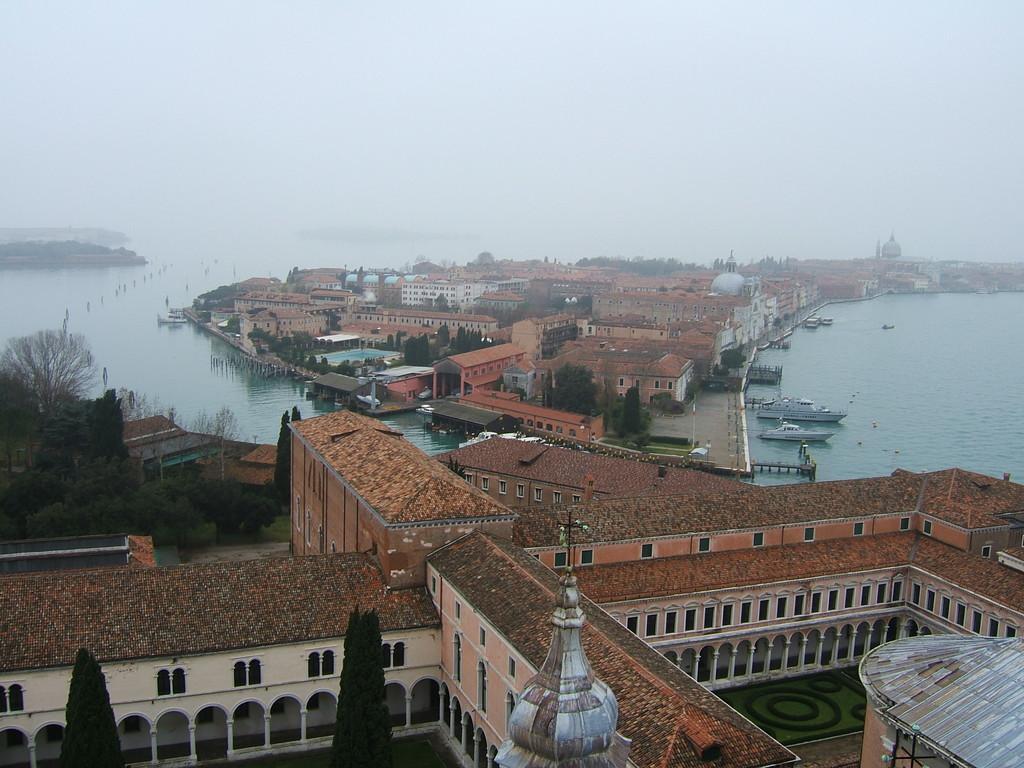Can you describe this image briefly? In this picture we can see some boats in water. There are few buildings and trees. We can see some arches on the building. 